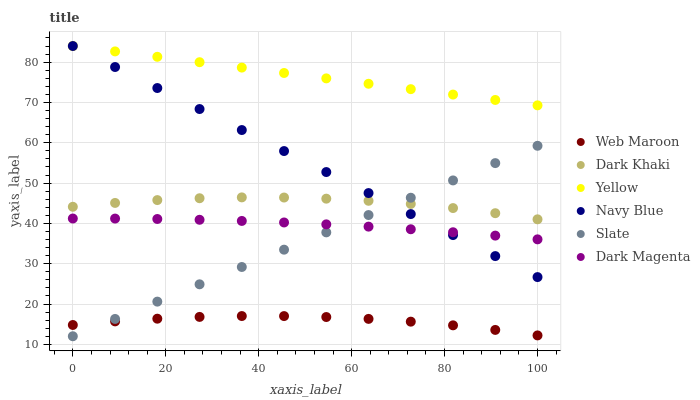Does Web Maroon have the minimum area under the curve?
Answer yes or no. Yes. Does Yellow have the maximum area under the curve?
Answer yes or no. Yes. Does Navy Blue have the minimum area under the curve?
Answer yes or no. No. Does Navy Blue have the maximum area under the curve?
Answer yes or no. No. Is Slate the smoothest?
Answer yes or no. Yes. Is Dark Khaki the roughest?
Answer yes or no. Yes. Is Navy Blue the smoothest?
Answer yes or no. No. Is Navy Blue the roughest?
Answer yes or no. No. Does Slate have the lowest value?
Answer yes or no. Yes. Does Navy Blue have the lowest value?
Answer yes or no. No. Does Yellow have the highest value?
Answer yes or no. Yes. Does Slate have the highest value?
Answer yes or no. No. Is Web Maroon less than Dark Magenta?
Answer yes or no. Yes. Is Navy Blue greater than Web Maroon?
Answer yes or no. Yes. Does Navy Blue intersect Slate?
Answer yes or no. Yes. Is Navy Blue less than Slate?
Answer yes or no. No. Is Navy Blue greater than Slate?
Answer yes or no. No. Does Web Maroon intersect Dark Magenta?
Answer yes or no. No. 